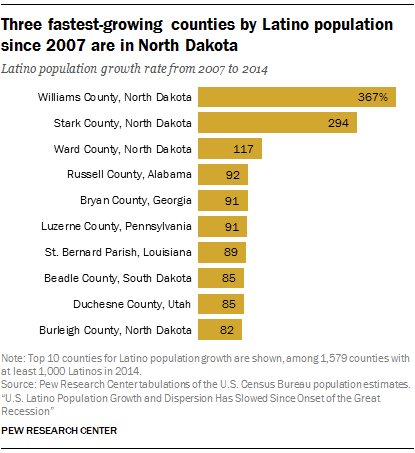List a handful of essential elements in this visual. The value of the smallest yellow bar is 82. The average of the two smallest blue bars is 83.5. 